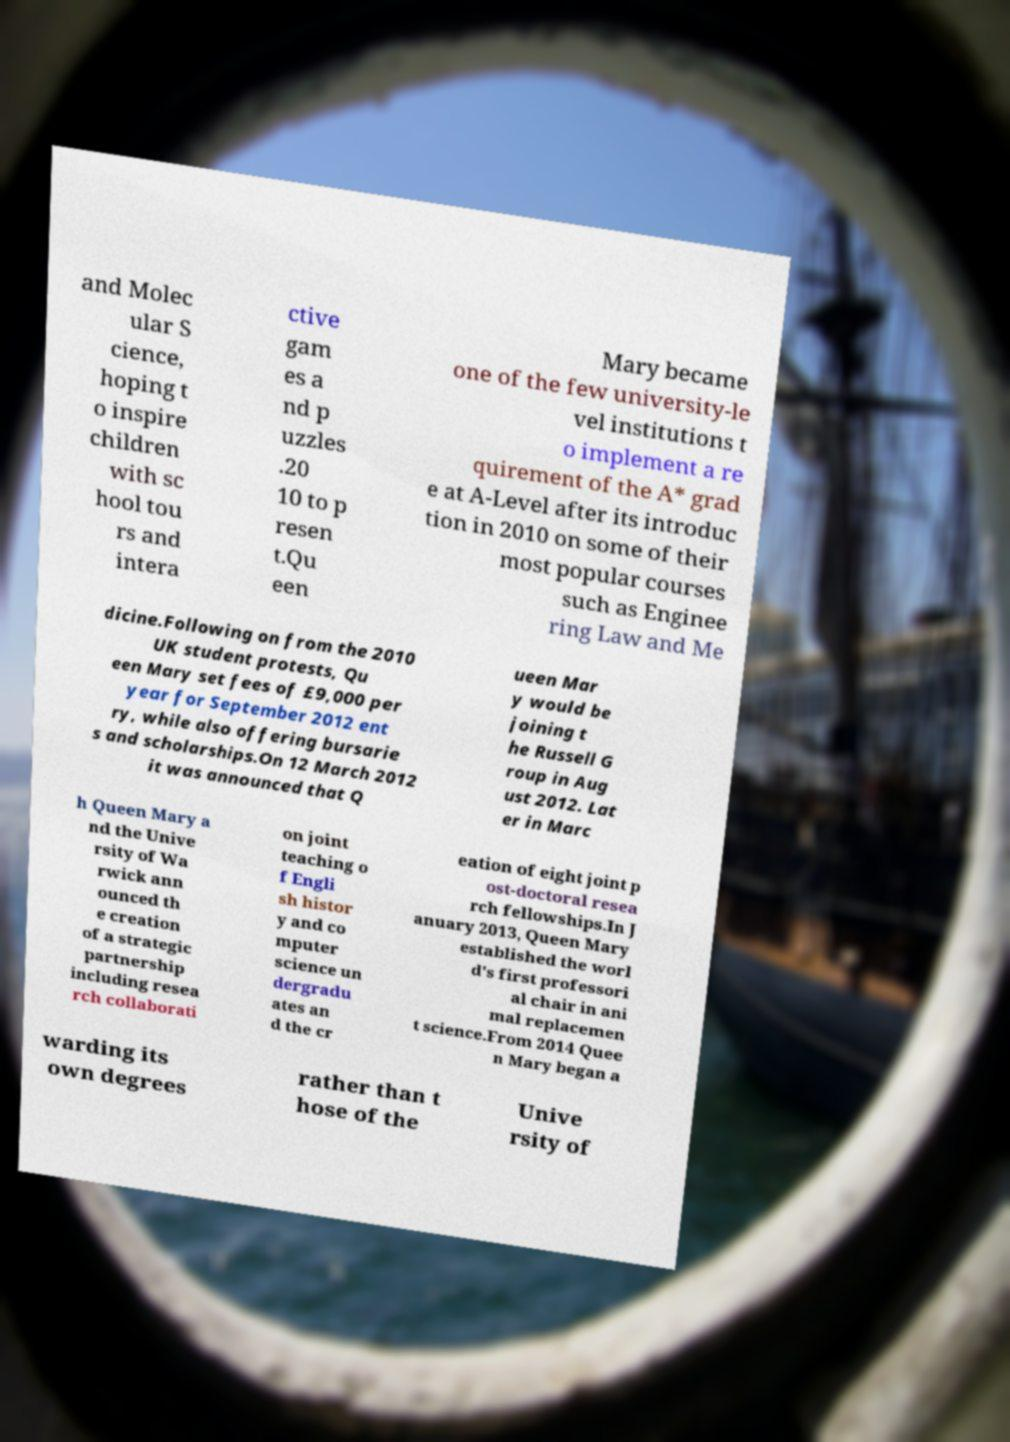Could you assist in decoding the text presented in this image and type it out clearly? and Molec ular S cience, hoping t o inspire children with sc hool tou rs and intera ctive gam es a nd p uzzles .20 10 to p resen t.Qu een Mary became one of the few university-le vel institutions t o implement a re quirement of the A* grad e at A-Level after its introduc tion in 2010 on some of their most popular courses such as Enginee ring Law and Me dicine.Following on from the 2010 UK student protests, Qu een Mary set fees of £9,000 per year for September 2012 ent ry, while also offering bursarie s and scholarships.On 12 March 2012 it was announced that Q ueen Mar y would be joining t he Russell G roup in Aug ust 2012. Lat er in Marc h Queen Mary a nd the Unive rsity of Wa rwick ann ounced th e creation of a strategic partnership including resea rch collaborati on joint teaching o f Engli sh histor y and co mputer science un dergradu ates an d the cr eation of eight joint p ost-doctoral resea rch fellowships.In J anuary 2013, Queen Mary established the worl d's first professori al chair in ani mal replacemen t science.From 2014 Quee n Mary began a warding its own degrees rather than t hose of the Unive rsity of 